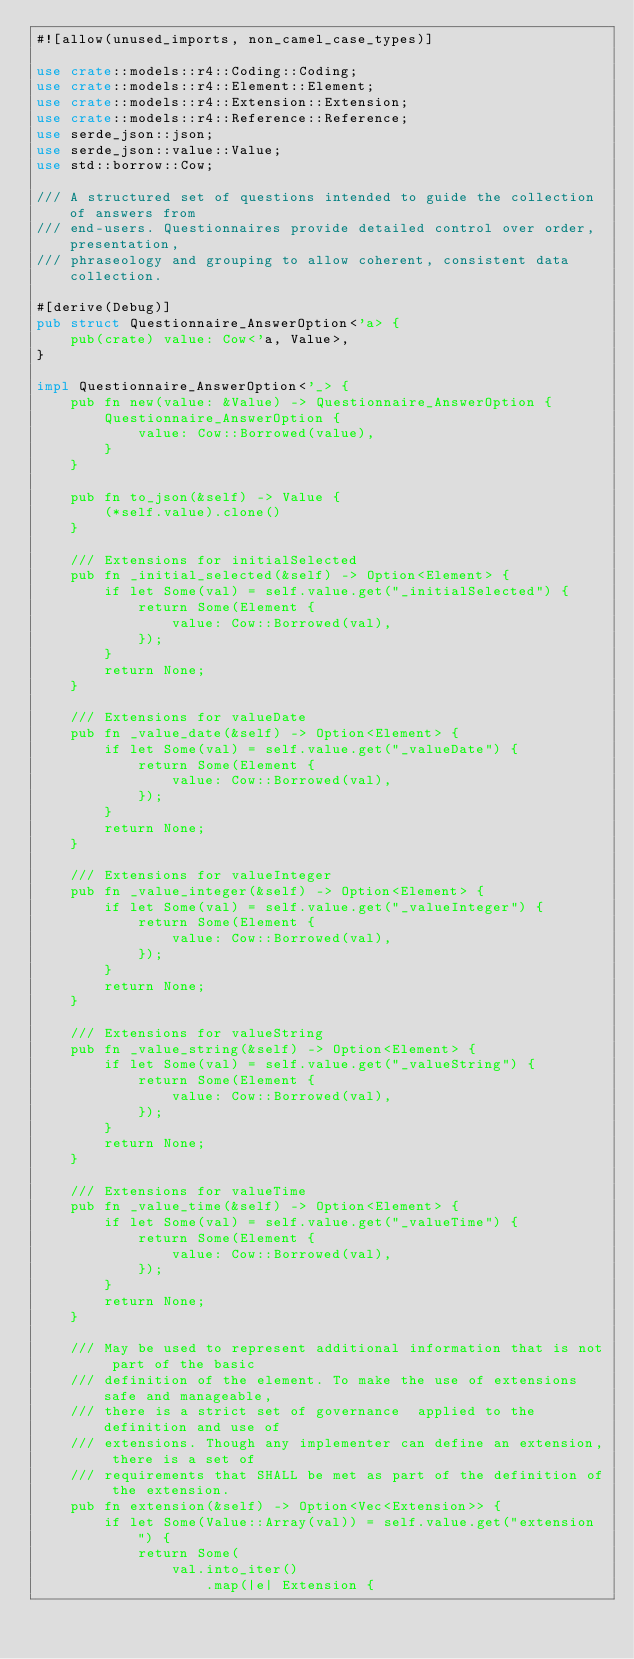<code> <loc_0><loc_0><loc_500><loc_500><_Rust_>#![allow(unused_imports, non_camel_case_types)]

use crate::models::r4::Coding::Coding;
use crate::models::r4::Element::Element;
use crate::models::r4::Extension::Extension;
use crate::models::r4::Reference::Reference;
use serde_json::json;
use serde_json::value::Value;
use std::borrow::Cow;

/// A structured set of questions intended to guide the collection of answers from
/// end-users. Questionnaires provide detailed control over order, presentation,
/// phraseology and grouping to allow coherent, consistent data collection.

#[derive(Debug)]
pub struct Questionnaire_AnswerOption<'a> {
    pub(crate) value: Cow<'a, Value>,
}

impl Questionnaire_AnswerOption<'_> {
    pub fn new(value: &Value) -> Questionnaire_AnswerOption {
        Questionnaire_AnswerOption {
            value: Cow::Borrowed(value),
        }
    }

    pub fn to_json(&self) -> Value {
        (*self.value).clone()
    }

    /// Extensions for initialSelected
    pub fn _initial_selected(&self) -> Option<Element> {
        if let Some(val) = self.value.get("_initialSelected") {
            return Some(Element {
                value: Cow::Borrowed(val),
            });
        }
        return None;
    }

    /// Extensions for valueDate
    pub fn _value_date(&self) -> Option<Element> {
        if let Some(val) = self.value.get("_valueDate") {
            return Some(Element {
                value: Cow::Borrowed(val),
            });
        }
        return None;
    }

    /// Extensions for valueInteger
    pub fn _value_integer(&self) -> Option<Element> {
        if let Some(val) = self.value.get("_valueInteger") {
            return Some(Element {
                value: Cow::Borrowed(val),
            });
        }
        return None;
    }

    /// Extensions for valueString
    pub fn _value_string(&self) -> Option<Element> {
        if let Some(val) = self.value.get("_valueString") {
            return Some(Element {
                value: Cow::Borrowed(val),
            });
        }
        return None;
    }

    /// Extensions for valueTime
    pub fn _value_time(&self) -> Option<Element> {
        if let Some(val) = self.value.get("_valueTime") {
            return Some(Element {
                value: Cow::Borrowed(val),
            });
        }
        return None;
    }

    /// May be used to represent additional information that is not part of the basic
    /// definition of the element. To make the use of extensions safe and manageable,
    /// there is a strict set of governance  applied to the definition and use of
    /// extensions. Though any implementer can define an extension, there is a set of
    /// requirements that SHALL be met as part of the definition of the extension.
    pub fn extension(&self) -> Option<Vec<Extension>> {
        if let Some(Value::Array(val)) = self.value.get("extension") {
            return Some(
                val.into_iter()
                    .map(|e| Extension {</code> 